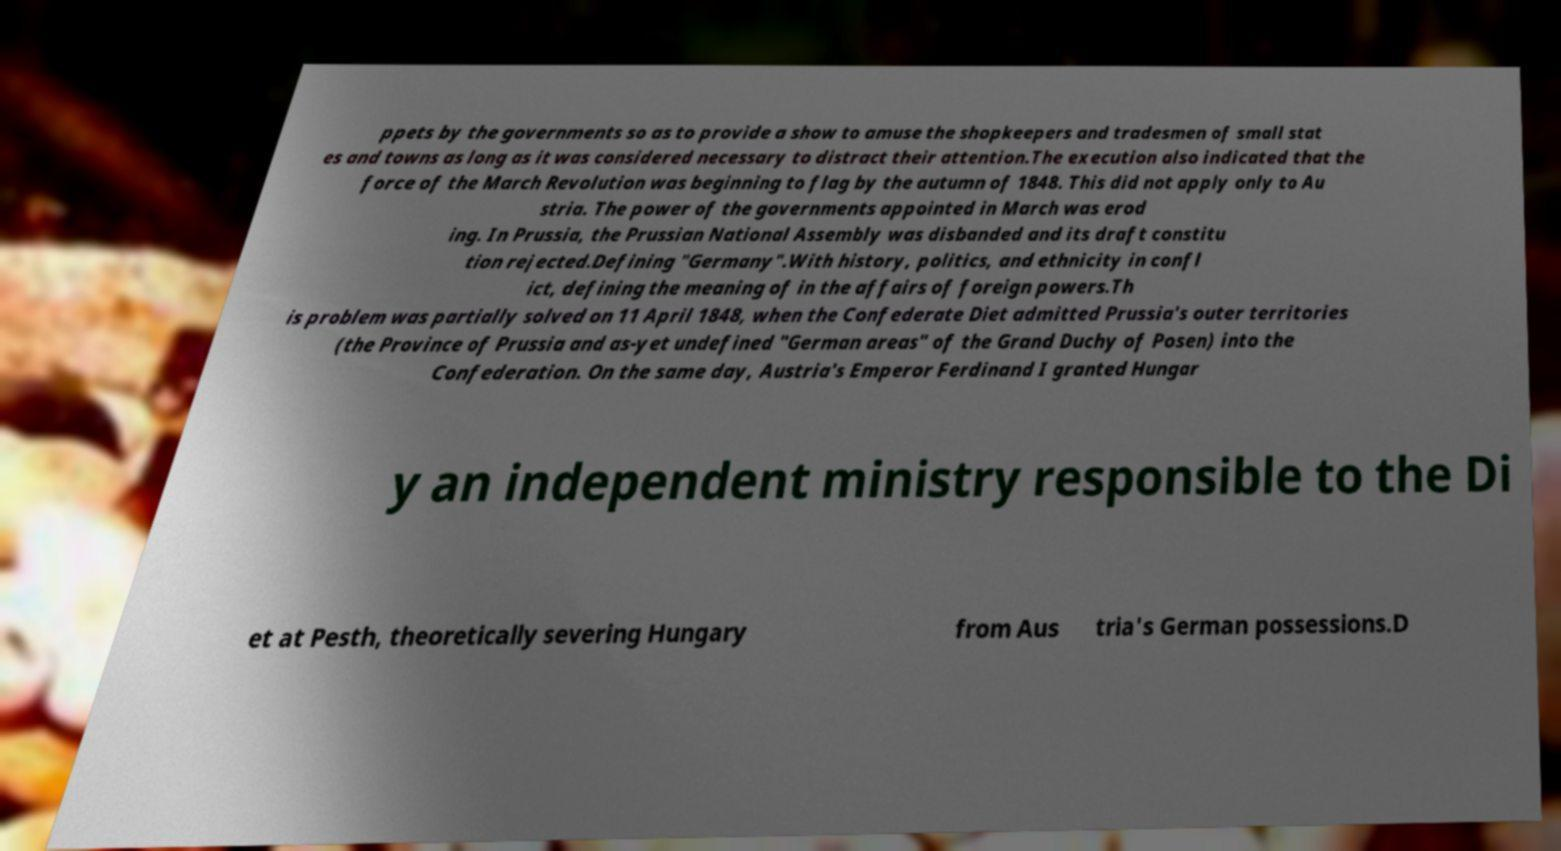What messages or text are displayed in this image? I need them in a readable, typed format. ppets by the governments so as to provide a show to amuse the shopkeepers and tradesmen of small stat es and towns as long as it was considered necessary to distract their attention.The execution also indicated that the force of the March Revolution was beginning to flag by the autumn of 1848. This did not apply only to Au stria. The power of the governments appointed in March was erod ing. In Prussia, the Prussian National Assembly was disbanded and its draft constitu tion rejected.Defining "Germany".With history, politics, and ethnicity in confl ict, defining the meaning of in the affairs of foreign powers.Th is problem was partially solved on 11 April 1848, when the Confederate Diet admitted Prussia's outer territories (the Province of Prussia and as-yet undefined "German areas" of the Grand Duchy of Posen) into the Confederation. On the same day, Austria's Emperor Ferdinand I granted Hungar y an independent ministry responsible to the Di et at Pesth, theoretically severing Hungary from Aus tria's German possessions.D 